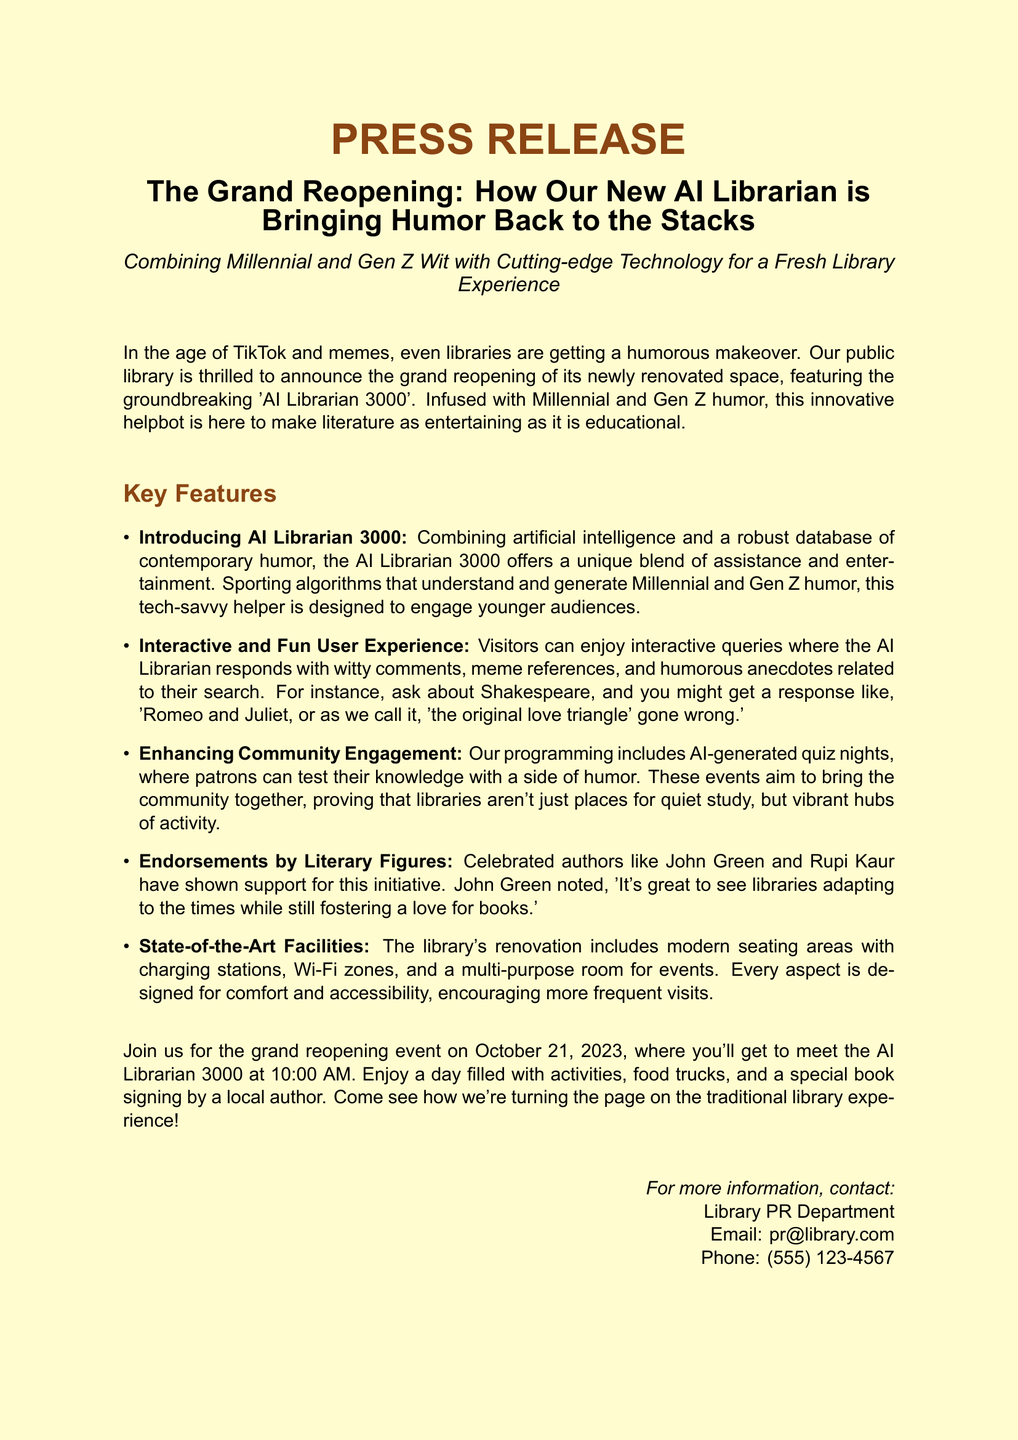What is the name of the new AI librarian? The document names the new AI librarian as 'AI Librarian 3000'.
Answer: AI Librarian 3000 When is the grand reopening event? The document states that the grand reopening event is on October 21, 2023.
Answer: October 21, 2023 Who endorsed the initiative? The document mentions that celebrated authors like John Green and Rupi Kaur have shown support for the initiative.
Answer: John Green and Rupi Kaur What kind of events does the library plan to host? The document outlines that the library will include AI-generated quiz nights as part of its programming.
Answer: AI-generated quiz nights How will the AI Librarian respond to user queries? According to the document, the AI Librarian responds with witty comments, meme references, and humorous anecdotes.
Answer: Witty comments, meme references, and humorous anecdotes What time does the grand reopening event start? The document specifies that the grand reopening event starts at 10:00 AM.
Answer: 10:00 AM What is the focus of the AI Librarian 3000? The document states that the focus of the AI Librarian 3000 is to engage younger audiences.
Answer: Engage younger audiences What modern features are included in the library's renovation? The document lists modern seating areas with charging stations, Wi-Fi zones, and a multi-purpose room as features of the renovation.
Answer: Modern seating areas, charging stations, Wi-Fi zones, multi-purpose room 